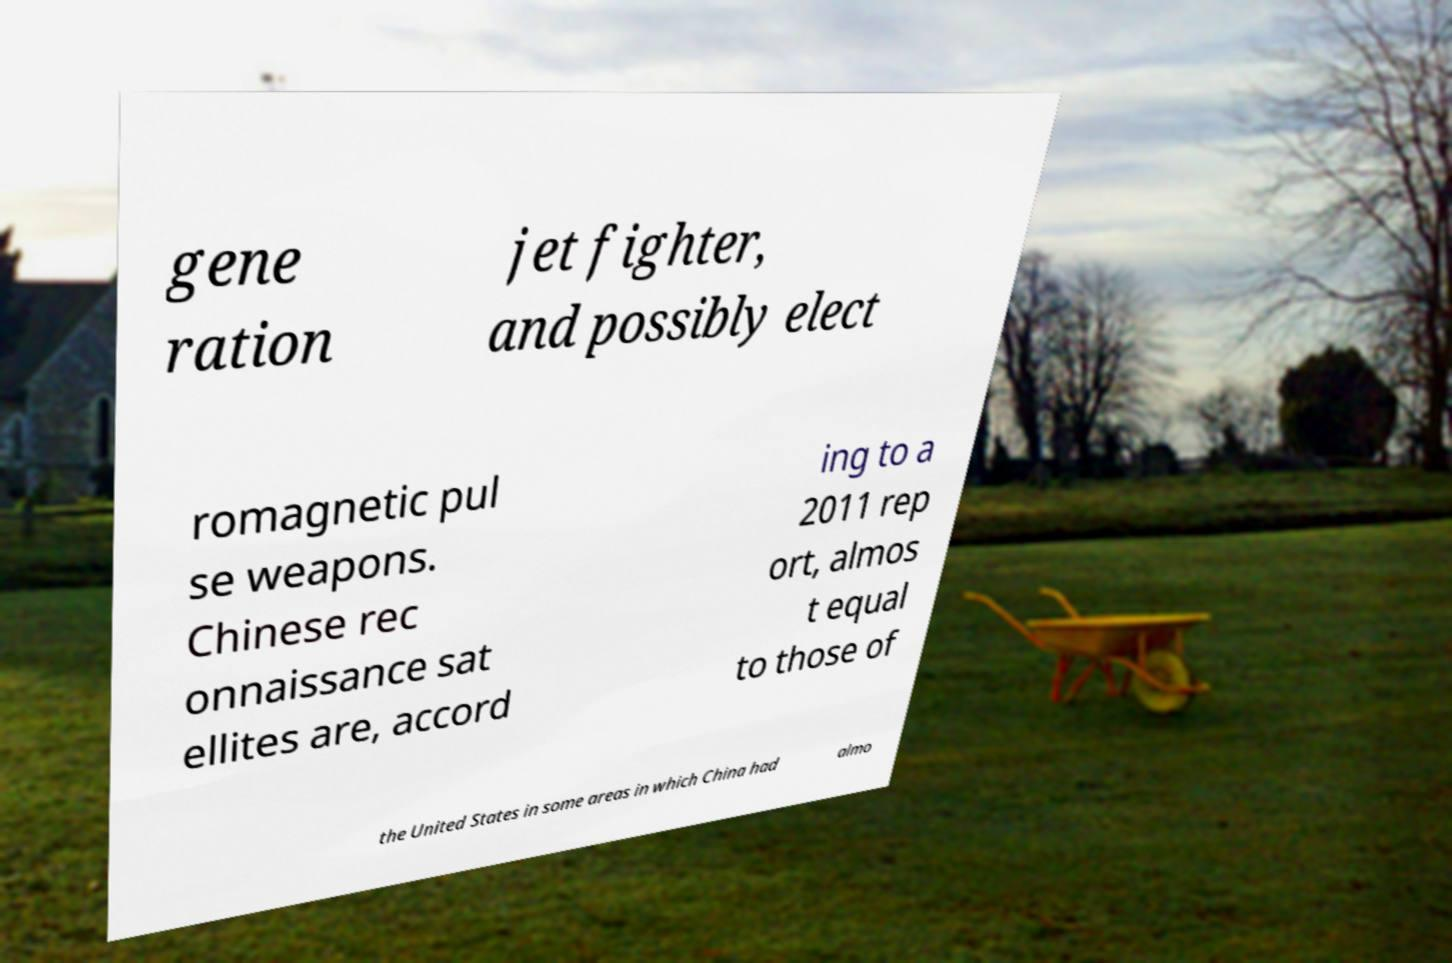There's text embedded in this image that I need extracted. Can you transcribe it verbatim? gene ration jet fighter, and possibly elect romagnetic pul se weapons. Chinese rec onnaissance sat ellites are, accord ing to a 2011 rep ort, almos t equal to those of the United States in some areas in which China had almo 